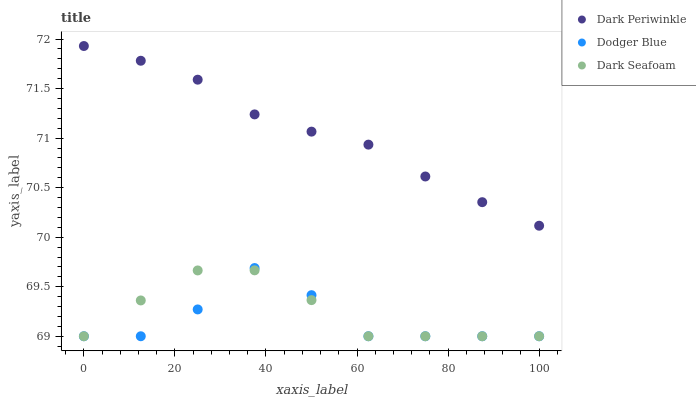Does Dodger Blue have the minimum area under the curve?
Answer yes or no. Yes. Does Dark Periwinkle have the maximum area under the curve?
Answer yes or no. Yes. Does Dark Periwinkle have the minimum area under the curve?
Answer yes or no. No. Does Dodger Blue have the maximum area under the curve?
Answer yes or no. No. Is Dark Periwinkle the smoothest?
Answer yes or no. Yes. Is Dodger Blue the roughest?
Answer yes or no. Yes. Is Dodger Blue the smoothest?
Answer yes or no. No. Is Dark Periwinkle the roughest?
Answer yes or no. No. Does Dark Seafoam have the lowest value?
Answer yes or no. Yes. Does Dark Periwinkle have the lowest value?
Answer yes or no. No. Does Dark Periwinkle have the highest value?
Answer yes or no. Yes. Does Dodger Blue have the highest value?
Answer yes or no. No. Is Dodger Blue less than Dark Periwinkle?
Answer yes or no. Yes. Is Dark Periwinkle greater than Dark Seafoam?
Answer yes or no. Yes. Does Dark Seafoam intersect Dodger Blue?
Answer yes or no. Yes. Is Dark Seafoam less than Dodger Blue?
Answer yes or no. No. Is Dark Seafoam greater than Dodger Blue?
Answer yes or no. No. Does Dodger Blue intersect Dark Periwinkle?
Answer yes or no. No. 